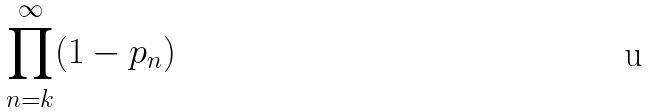<formula> <loc_0><loc_0><loc_500><loc_500>\prod _ { n = k } ^ { \infty } ( 1 - p _ { n } )</formula> 